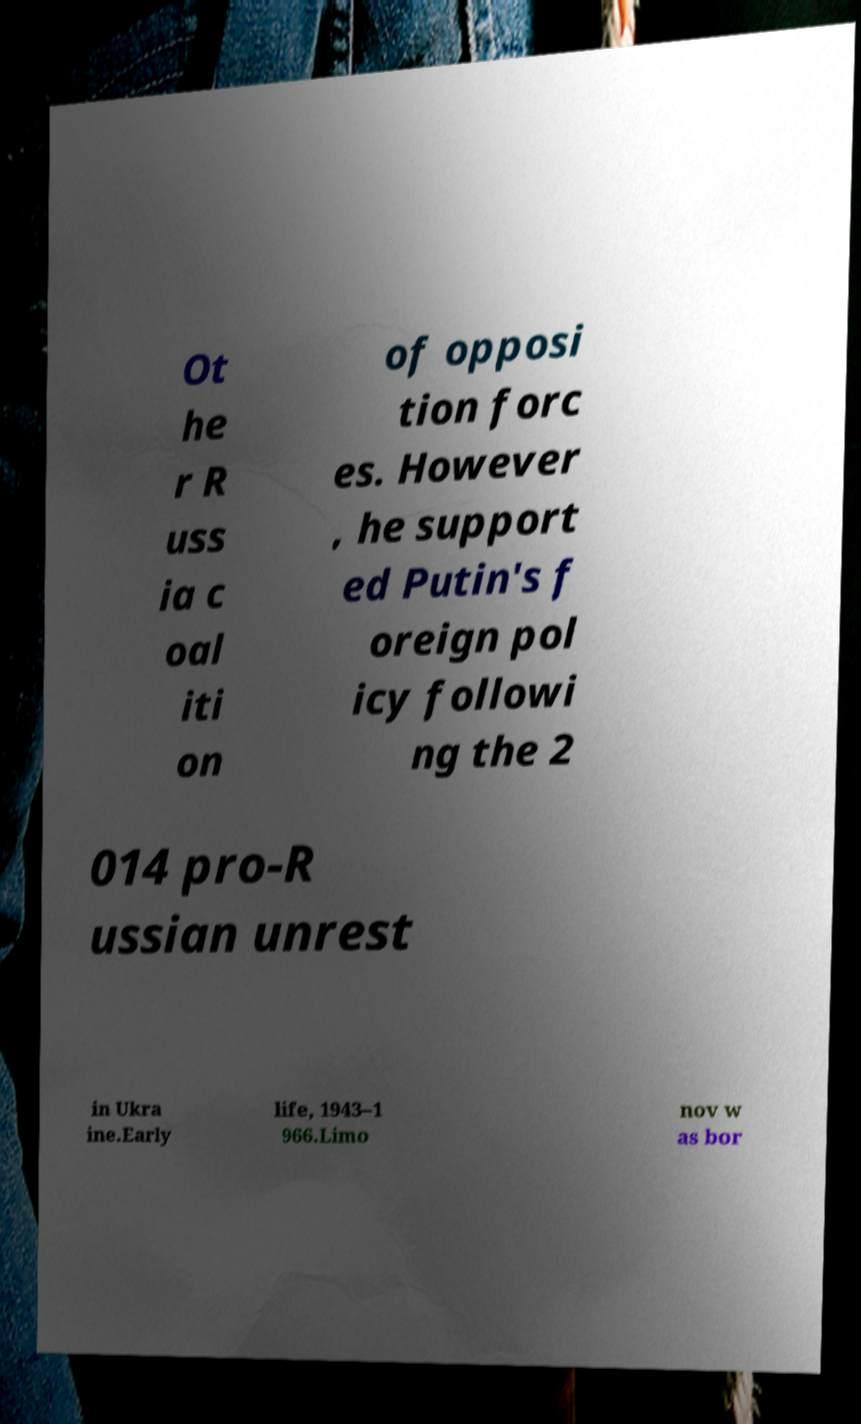Can you accurately transcribe the text from the provided image for me? Ot he r R uss ia c oal iti on of opposi tion forc es. However , he support ed Putin's f oreign pol icy followi ng the 2 014 pro-R ussian unrest in Ukra ine.Early life, 1943–1 966.Limo nov w as bor 